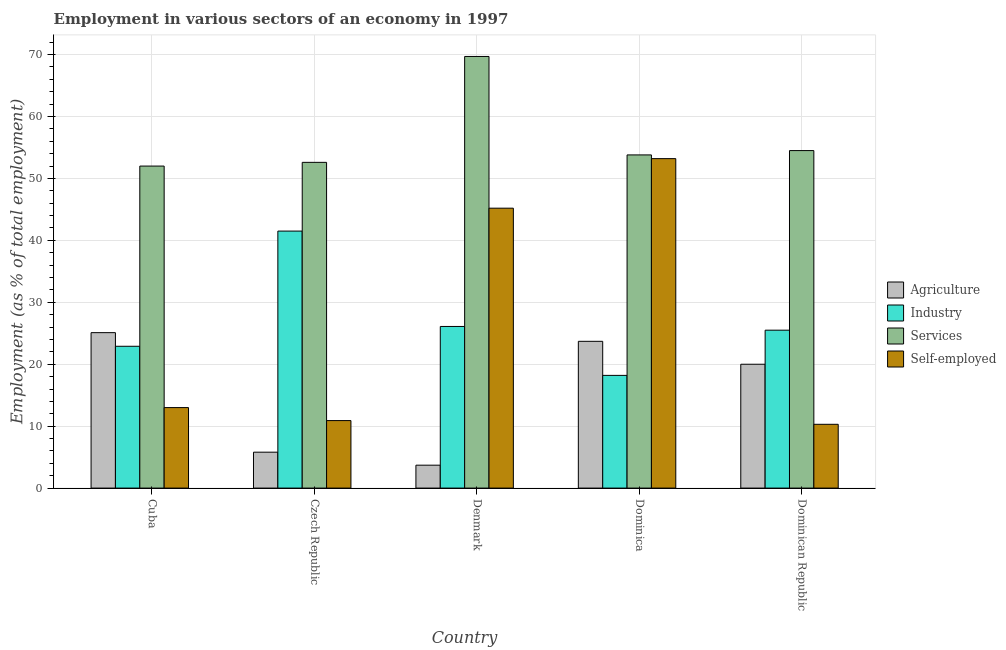How many groups of bars are there?
Your answer should be very brief. 5. Are the number of bars per tick equal to the number of legend labels?
Give a very brief answer. Yes. What is the label of the 4th group of bars from the left?
Your answer should be very brief. Dominica. In how many cases, is the number of bars for a given country not equal to the number of legend labels?
Offer a terse response. 0. What is the percentage of self employed workers in Dominican Republic?
Ensure brevity in your answer.  10.3. Across all countries, what is the maximum percentage of workers in agriculture?
Ensure brevity in your answer.  25.1. Across all countries, what is the minimum percentage of workers in agriculture?
Provide a succinct answer. 3.7. In which country was the percentage of workers in services maximum?
Your answer should be very brief. Denmark. In which country was the percentage of workers in services minimum?
Keep it short and to the point. Cuba. What is the total percentage of workers in agriculture in the graph?
Your response must be concise. 78.3. What is the difference between the percentage of workers in industry in Cuba and that in Denmark?
Offer a terse response. -3.2. What is the difference between the percentage of workers in agriculture in Cuba and the percentage of self employed workers in Dominica?
Provide a succinct answer. -28.1. What is the average percentage of self employed workers per country?
Make the answer very short. 26.52. What is the difference between the percentage of workers in industry and percentage of workers in services in Cuba?
Keep it short and to the point. -29.1. In how many countries, is the percentage of workers in agriculture greater than 26 %?
Provide a succinct answer. 0. What is the ratio of the percentage of workers in industry in Cuba to that in Czech Republic?
Offer a terse response. 0.55. Is the percentage of workers in industry in Denmark less than that in Dominica?
Offer a very short reply. No. Is the difference between the percentage of workers in agriculture in Czech Republic and Denmark greater than the difference between the percentage of workers in services in Czech Republic and Denmark?
Offer a very short reply. Yes. What is the difference between the highest and the second highest percentage of workers in agriculture?
Offer a very short reply. 1.4. What is the difference between the highest and the lowest percentage of workers in agriculture?
Offer a terse response. 21.4. Is it the case that in every country, the sum of the percentage of workers in services and percentage of workers in industry is greater than the sum of percentage of self employed workers and percentage of workers in agriculture?
Your response must be concise. No. What does the 2nd bar from the left in Czech Republic represents?
Ensure brevity in your answer.  Industry. What does the 4th bar from the right in Dominican Republic represents?
Your response must be concise. Agriculture. How many bars are there?
Ensure brevity in your answer.  20. Are all the bars in the graph horizontal?
Make the answer very short. No. How many countries are there in the graph?
Keep it short and to the point. 5. What is the difference between two consecutive major ticks on the Y-axis?
Your answer should be compact. 10. Are the values on the major ticks of Y-axis written in scientific E-notation?
Provide a succinct answer. No. Does the graph contain any zero values?
Make the answer very short. No. Where does the legend appear in the graph?
Keep it short and to the point. Center right. How many legend labels are there?
Provide a short and direct response. 4. What is the title of the graph?
Keep it short and to the point. Employment in various sectors of an economy in 1997. What is the label or title of the Y-axis?
Offer a terse response. Employment (as % of total employment). What is the Employment (as % of total employment) in Agriculture in Cuba?
Offer a terse response. 25.1. What is the Employment (as % of total employment) of Industry in Cuba?
Offer a terse response. 22.9. What is the Employment (as % of total employment) in Agriculture in Czech Republic?
Give a very brief answer. 5.8. What is the Employment (as % of total employment) in Industry in Czech Republic?
Your answer should be compact. 41.5. What is the Employment (as % of total employment) in Services in Czech Republic?
Make the answer very short. 52.6. What is the Employment (as % of total employment) in Self-employed in Czech Republic?
Give a very brief answer. 10.9. What is the Employment (as % of total employment) in Agriculture in Denmark?
Make the answer very short. 3.7. What is the Employment (as % of total employment) in Industry in Denmark?
Give a very brief answer. 26.1. What is the Employment (as % of total employment) in Services in Denmark?
Offer a very short reply. 69.7. What is the Employment (as % of total employment) in Self-employed in Denmark?
Keep it short and to the point. 45.2. What is the Employment (as % of total employment) of Agriculture in Dominica?
Ensure brevity in your answer.  23.7. What is the Employment (as % of total employment) of Industry in Dominica?
Provide a short and direct response. 18.2. What is the Employment (as % of total employment) in Services in Dominica?
Your answer should be very brief. 53.8. What is the Employment (as % of total employment) in Self-employed in Dominica?
Provide a short and direct response. 53.2. What is the Employment (as % of total employment) of Services in Dominican Republic?
Make the answer very short. 54.5. What is the Employment (as % of total employment) in Self-employed in Dominican Republic?
Give a very brief answer. 10.3. Across all countries, what is the maximum Employment (as % of total employment) in Agriculture?
Your answer should be compact. 25.1. Across all countries, what is the maximum Employment (as % of total employment) of Industry?
Provide a succinct answer. 41.5. Across all countries, what is the maximum Employment (as % of total employment) of Services?
Make the answer very short. 69.7. Across all countries, what is the maximum Employment (as % of total employment) of Self-employed?
Make the answer very short. 53.2. Across all countries, what is the minimum Employment (as % of total employment) in Agriculture?
Offer a terse response. 3.7. Across all countries, what is the minimum Employment (as % of total employment) in Industry?
Offer a terse response. 18.2. Across all countries, what is the minimum Employment (as % of total employment) of Services?
Your answer should be compact. 52. Across all countries, what is the minimum Employment (as % of total employment) of Self-employed?
Offer a terse response. 10.3. What is the total Employment (as % of total employment) of Agriculture in the graph?
Ensure brevity in your answer.  78.3. What is the total Employment (as % of total employment) in Industry in the graph?
Your response must be concise. 134.2. What is the total Employment (as % of total employment) in Services in the graph?
Provide a succinct answer. 282.6. What is the total Employment (as % of total employment) of Self-employed in the graph?
Offer a terse response. 132.6. What is the difference between the Employment (as % of total employment) in Agriculture in Cuba and that in Czech Republic?
Provide a short and direct response. 19.3. What is the difference between the Employment (as % of total employment) of Industry in Cuba and that in Czech Republic?
Offer a very short reply. -18.6. What is the difference between the Employment (as % of total employment) of Services in Cuba and that in Czech Republic?
Ensure brevity in your answer.  -0.6. What is the difference between the Employment (as % of total employment) in Self-employed in Cuba and that in Czech Republic?
Offer a very short reply. 2.1. What is the difference between the Employment (as % of total employment) in Agriculture in Cuba and that in Denmark?
Provide a succinct answer. 21.4. What is the difference between the Employment (as % of total employment) in Services in Cuba and that in Denmark?
Your answer should be very brief. -17.7. What is the difference between the Employment (as % of total employment) of Self-employed in Cuba and that in Denmark?
Your response must be concise. -32.2. What is the difference between the Employment (as % of total employment) in Agriculture in Cuba and that in Dominica?
Your answer should be very brief. 1.4. What is the difference between the Employment (as % of total employment) of Services in Cuba and that in Dominica?
Ensure brevity in your answer.  -1.8. What is the difference between the Employment (as % of total employment) of Self-employed in Cuba and that in Dominica?
Offer a very short reply. -40.2. What is the difference between the Employment (as % of total employment) of Agriculture in Cuba and that in Dominican Republic?
Offer a terse response. 5.1. What is the difference between the Employment (as % of total employment) of Industry in Cuba and that in Dominican Republic?
Make the answer very short. -2.6. What is the difference between the Employment (as % of total employment) of Agriculture in Czech Republic and that in Denmark?
Your answer should be very brief. 2.1. What is the difference between the Employment (as % of total employment) of Services in Czech Republic and that in Denmark?
Ensure brevity in your answer.  -17.1. What is the difference between the Employment (as % of total employment) of Self-employed in Czech Republic and that in Denmark?
Offer a very short reply. -34.3. What is the difference between the Employment (as % of total employment) in Agriculture in Czech Republic and that in Dominica?
Your answer should be compact. -17.9. What is the difference between the Employment (as % of total employment) in Industry in Czech Republic and that in Dominica?
Give a very brief answer. 23.3. What is the difference between the Employment (as % of total employment) of Services in Czech Republic and that in Dominica?
Ensure brevity in your answer.  -1.2. What is the difference between the Employment (as % of total employment) in Self-employed in Czech Republic and that in Dominica?
Keep it short and to the point. -42.3. What is the difference between the Employment (as % of total employment) of Agriculture in Czech Republic and that in Dominican Republic?
Your answer should be very brief. -14.2. What is the difference between the Employment (as % of total employment) of Services in Czech Republic and that in Dominican Republic?
Make the answer very short. -1.9. What is the difference between the Employment (as % of total employment) of Self-employed in Czech Republic and that in Dominican Republic?
Provide a succinct answer. 0.6. What is the difference between the Employment (as % of total employment) in Agriculture in Denmark and that in Dominica?
Provide a short and direct response. -20. What is the difference between the Employment (as % of total employment) of Agriculture in Denmark and that in Dominican Republic?
Your answer should be compact. -16.3. What is the difference between the Employment (as % of total employment) of Industry in Denmark and that in Dominican Republic?
Your answer should be very brief. 0.6. What is the difference between the Employment (as % of total employment) in Self-employed in Denmark and that in Dominican Republic?
Provide a short and direct response. 34.9. What is the difference between the Employment (as % of total employment) in Industry in Dominica and that in Dominican Republic?
Your answer should be very brief. -7.3. What is the difference between the Employment (as % of total employment) of Self-employed in Dominica and that in Dominican Republic?
Offer a very short reply. 42.9. What is the difference between the Employment (as % of total employment) of Agriculture in Cuba and the Employment (as % of total employment) of Industry in Czech Republic?
Your answer should be compact. -16.4. What is the difference between the Employment (as % of total employment) of Agriculture in Cuba and the Employment (as % of total employment) of Services in Czech Republic?
Offer a terse response. -27.5. What is the difference between the Employment (as % of total employment) of Industry in Cuba and the Employment (as % of total employment) of Services in Czech Republic?
Give a very brief answer. -29.7. What is the difference between the Employment (as % of total employment) in Industry in Cuba and the Employment (as % of total employment) in Self-employed in Czech Republic?
Provide a short and direct response. 12. What is the difference between the Employment (as % of total employment) in Services in Cuba and the Employment (as % of total employment) in Self-employed in Czech Republic?
Provide a short and direct response. 41.1. What is the difference between the Employment (as % of total employment) of Agriculture in Cuba and the Employment (as % of total employment) of Services in Denmark?
Your response must be concise. -44.6. What is the difference between the Employment (as % of total employment) of Agriculture in Cuba and the Employment (as % of total employment) of Self-employed in Denmark?
Offer a very short reply. -20.1. What is the difference between the Employment (as % of total employment) of Industry in Cuba and the Employment (as % of total employment) of Services in Denmark?
Offer a terse response. -46.8. What is the difference between the Employment (as % of total employment) of Industry in Cuba and the Employment (as % of total employment) of Self-employed in Denmark?
Ensure brevity in your answer.  -22.3. What is the difference between the Employment (as % of total employment) of Services in Cuba and the Employment (as % of total employment) of Self-employed in Denmark?
Keep it short and to the point. 6.8. What is the difference between the Employment (as % of total employment) of Agriculture in Cuba and the Employment (as % of total employment) of Services in Dominica?
Provide a short and direct response. -28.7. What is the difference between the Employment (as % of total employment) of Agriculture in Cuba and the Employment (as % of total employment) of Self-employed in Dominica?
Offer a terse response. -28.1. What is the difference between the Employment (as % of total employment) in Industry in Cuba and the Employment (as % of total employment) in Services in Dominica?
Your response must be concise. -30.9. What is the difference between the Employment (as % of total employment) in Industry in Cuba and the Employment (as % of total employment) in Self-employed in Dominica?
Provide a succinct answer. -30.3. What is the difference between the Employment (as % of total employment) of Services in Cuba and the Employment (as % of total employment) of Self-employed in Dominica?
Keep it short and to the point. -1.2. What is the difference between the Employment (as % of total employment) of Agriculture in Cuba and the Employment (as % of total employment) of Services in Dominican Republic?
Your response must be concise. -29.4. What is the difference between the Employment (as % of total employment) in Industry in Cuba and the Employment (as % of total employment) in Services in Dominican Republic?
Give a very brief answer. -31.6. What is the difference between the Employment (as % of total employment) in Industry in Cuba and the Employment (as % of total employment) in Self-employed in Dominican Republic?
Your response must be concise. 12.6. What is the difference between the Employment (as % of total employment) of Services in Cuba and the Employment (as % of total employment) of Self-employed in Dominican Republic?
Ensure brevity in your answer.  41.7. What is the difference between the Employment (as % of total employment) of Agriculture in Czech Republic and the Employment (as % of total employment) of Industry in Denmark?
Offer a very short reply. -20.3. What is the difference between the Employment (as % of total employment) in Agriculture in Czech Republic and the Employment (as % of total employment) in Services in Denmark?
Offer a terse response. -63.9. What is the difference between the Employment (as % of total employment) in Agriculture in Czech Republic and the Employment (as % of total employment) in Self-employed in Denmark?
Ensure brevity in your answer.  -39.4. What is the difference between the Employment (as % of total employment) of Industry in Czech Republic and the Employment (as % of total employment) of Services in Denmark?
Your response must be concise. -28.2. What is the difference between the Employment (as % of total employment) of Industry in Czech Republic and the Employment (as % of total employment) of Self-employed in Denmark?
Offer a very short reply. -3.7. What is the difference between the Employment (as % of total employment) in Services in Czech Republic and the Employment (as % of total employment) in Self-employed in Denmark?
Provide a short and direct response. 7.4. What is the difference between the Employment (as % of total employment) of Agriculture in Czech Republic and the Employment (as % of total employment) of Services in Dominica?
Make the answer very short. -48. What is the difference between the Employment (as % of total employment) of Agriculture in Czech Republic and the Employment (as % of total employment) of Self-employed in Dominica?
Make the answer very short. -47.4. What is the difference between the Employment (as % of total employment) of Industry in Czech Republic and the Employment (as % of total employment) of Services in Dominica?
Give a very brief answer. -12.3. What is the difference between the Employment (as % of total employment) in Agriculture in Czech Republic and the Employment (as % of total employment) in Industry in Dominican Republic?
Provide a short and direct response. -19.7. What is the difference between the Employment (as % of total employment) in Agriculture in Czech Republic and the Employment (as % of total employment) in Services in Dominican Republic?
Provide a succinct answer. -48.7. What is the difference between the Employment (as % of total employment) of Industry in Czech Republic and the Employment (as % of total employment) of Services in Dominican Republic?
Give a very brief answer. -13. What is the difference between the Employment (as % of total employment) of Industry in Czech Republic and the Employment (as % of total employment) of Self-employed in Dominican Republic?
Offer a terse response. 31.2. What is the difference between the Employment (as % of total employment) in Services in Czech Republic and the Employment (as % of total employment) in Self-employed in Dominican Republic?
Ensure brevity in your answer.  42.3. What is the difference between the Employment (as % of total employment) in Agriculture in Denmark and the Employment (as % of total employment) in Industry in Dominica?
Give a very brief answer. -14.5. What is the difference between the Employment (as % of total employment) of Agriculture in Denmark and the Employment (as % of total employment) of Services in Dominica?
Keep it short and to the point. -50.1. What is the difference between the Employment (as % of total employment) in Agriculture in Denmark and the Employment (as % of total employment) in Self-employed in Dominica?
Keep it short and to the point. -49.5. What is the difference between the Employment (as % of total employment) of Industry in Denmark and the Employment (as % of total employment) of Services in Dominica?
Your response must be concise. -27.7. What is the difference between the Employment (as % of total employment) of Industry in Denmark and the Employment (as % of total employment) of Self-employed in Dominica?
Ensure brevity in your answer.  -27.1. What is the difference between the Employment (as % of total employment) of Agriculture in Denmark and the Employment (as % of total employment) of Industry in Dominican Republic?
Provide a short and direct response. -21.8. What is the difference between the Employment (as % of total employment) in Agriculture in Denmark and the Employment (as % of total employment) in Services in Dominican Republic?
Offer a terse response. -50.8. What is the difference between the Employment (as % of total employment) in Agriculture in Denmark and the Employment (as % of total employment) in Self-employed in Dominican Republic?
Ensure brevity in your answer.  -6.6. What is the difference between the Employment (as % of total employment) of Industry in Denmark and the Employment (as % of total employment) of Services in Dominican Republic?
Ensure brevity in your answer.  -28.4. What is the difference between the Employment (as % of total employment) of Industry in Denmark and the Employment (as % of total employment) of Self-employed in Dominican Republic?
Ensure brevity in your answer.  15.8. What is the difference between the Employment (as % of total employment) of Services in Denmark and the Employment (as % of total employment) of Self-employed in Dominican Republic?
Provide a short and direct response. 59.4. What is the difference between the Employment (as % of total employment) in Agriculture in Dominica and the Employment (as % of total employment) in Services in Dominican Republic?
Offer a terse response. -30.8. What is the difference between the Employment (as % of total employment) in Agriculture in Dominica and the Employment (as % of total employment) in Self-employed in Dominican Republic?
Offer a very short reply. 13.4. What is the difference between the Employment (as % of total employment) of Industry in Dominica and the Employment (as % of total employment) of Services in Dominican Republic?
Ensure brevity in your answer.  -36.3. What is the difference between the Employment (as % of total employment) in Industry in Dominica and the Employment (as % of total employment) in Self-employed in Dominican Republic?
Your answer should be compact. 7.9. What is the difference between the Employment (as % of total employment) of Services in Dominica and the Employment (as % of total employment) of Self-employed in Dominican Republic?
Offer a very short reply. 43.5. What is the average Employment (as % of total employment) of Agriculture per country?
Provide a short and direct response. 15.66. What is the average Employment (as % of total employment) of Industry per country?
Offer a terse response. 26.84. What is the average Employment (as % of total employment) of Services per country?
Your response must be concise. 56.52. What is the average Employment (as % of total employment) of Self-employed per country?
Your answer should be compact. 26.52. What is the difference between the Employment (as % of total employment) of Agriculture and Employment (as % of total employment) of Industry in Cuba?
Offer a very short reply. 2.2. What is the difference between the Employment (as % of total employment) of Agriculture and Employment (as % of total employment) of Services in Cuba?
Provide a succinct answer. -26.9. What is the difference between the Employment (as % of total employment) in Industry and Employment (as % of total employment) in Services in Cuba?
Provide a succinct answer. -29.1. What is the difference between the Employment (as % of total employment) in Services and Employment (as % of total employment) in Self-employed in Cuba?
Provide a short and direct response. 39. What is the difference between the Employment (as % of total employment) of Agriculture and Employment (as % of total employment) of Industry in Czech Republic?
Your response must be concise. -35.7. What is the difference between the Employment (as % of total employment) in Agriculture and Employment (as % of total employment) in Services in Czech Republic?
Offer a terse response. -46.8. What is the difference between the Employment (as % of total employment) in Agriculture and Employment (as % of total employment) in Self-employed in Czech Republic?
Offer a very short reply. -5.1. What is the difference between the Employment (as % of total employment) in Industry and Employment (as % of total employment) in Self-employed in Czech Republic?
Offer a terse response. 30.6. What is the difference between the Employment (as % of total employment) in Services and Employment (as % of total employment) in Self-employed in Czech Republic?
Your response must be concise. 41.7. What is the difference between the Employment (as % of total employment) in Agriculture and Employment (as % of total employment) in Industry in Denmark?
Keep it short and to the point. -22.4. What is the difference between the Employment (as % of total employment) of Agriculture and Employment (as % of total employment) of Services in Denmark?
Offer a terse response. -66. What is the difference between the Employment (as % of total employment) of Agriculture and Employment (as % of total employment) of Self-employed in Denmark?
Offer a very short reply. -41.5. What is the difference between the Employment (as % of total employment) in Industry and Employment (as % of total employment) in Services in Denmark?
Give a very brief answer. -43.6. What is the difference between the Employment (as % of total employment) of Industry and Employment (as % of total employment) of Self-employed in Denmark?
Keep it short and to the point. -19.1. What is the difference between the Employment (as % of total employment) of Agriculture and Employment (as % of total employment) of Industry in Dominica?
Provide a succinct answer. 5.5. What is the difference between the Employment (as % of total employment) of Agriculture and Employment (as % of total employment) of Services in Dominica?
Provide a short and direct response. -30.1. What is the difference between the Employment (as % of total employment) of Agriculture and Employment (as % of total employment) of Self-employed in Dominica?
Offer a very short reply. -29.5. What is the difference between the Employment (as % of total employment) in Industry and Employment (as % of total employment) in Services in Dominica?
Make the answer very short. -35.6. What is the difference between the Employment (as % of total employment) of Industry and Employment (as % of total employment) of Self-employed in Dominica?
Provide a succinct answer. -35. What is the difference between the Employment (as % of total employment) of Agriculture and Employment (as % of total employment) of Industry in Dominican Republic?
Make the answer very short. -5.5. What is the difference between the Employment (as % of total employment) in Agriculture and Employment (as % of total employment) in Services in Dominican Republic?
Make the answer very short. -34.5. What is the difference between the Employment (as % of total employment) in Agriculture and Employment (as % of total employment) in Self-employed in Dominican Republic?
Your answer should be very brief. 9.7. What is the difference between the Employment (as % of total employment) in Industry and Employment (as % of total employment) in Self-employed in Dominican Republic?
Ensure brevity in your answer.  15.2. What is the difference between the Employment (as % of total employment) in Services and Employment (as % of total employment) in Self-employed in Dominican Republic?
Offer a very short reply. 44.2. What is the ratio of the Employment (as % of total employment) of Agriculture in Cuba to that in Czech Republic?
Give a very brief answer. 4.33. What is the ratio of the Employment (as % of total employment) in Industry in Cuba to that in Czech Republic?
Your response must be concise. 0.55. What is the ratio of the Employment (as % of total employment) of Self-employed in Cuba to that in Czech Republic?
Your answer should be compact. 1.19. What is the ratio of the Employment (as % of total employment) of Agriculture in Cuba to that in Denmark?
Provide a succinct answer. 6.78. What is the ratio of the Employment (as % of total employment) of Industry in Cuba to that in Denmark?
Give a very brief answer. 0.88. What is the ratio of the Employment (as % of total employment) in Services in Cuba to that in Denmark?
Your answer should be very brief. 0.75. What is the ratio of the Employment (as % of total employment) of Self-employed in Cuba to that in Denmark?
Ensure brevity in your answer.  0.29. What is the ratio of the Employment (as % of total employment) in Agriculture in Cuba to that in Dominica?
Your answer should be compact. 1.06. What is the ratio of the Employment (as % of total employment) of Industry in Cuba to that in Dominica?
Give a very brief answer. 1.26. What is the ratio of the Employment (as % of total employment) of Services in Cuba to that in Dominica?
Give a very brief answer. 0.97. What is the ratio of the Employment (as % of total employment) in Self-employed in Cuba to that in Dominica?
Your response must be concise. 0.24. What is the ratio of the Employment (as % of total employment) in Agriculture in Cuba to that in Dominican Republic?
Keep it short and to the point. 1.25. What is the ratio of the Employment (as % of total employment) of Industry in Cuba to that in Dominican Republic?
Ensure brevity in your answer.  0.9. What is the ratio of the Employment (as % of total employment) of Services in Cuba to that in Dominican Republic?
Offer a terse response. 0.95. What is the ratio of the Employment (as % of total employment) of Self-employed in Cuba to that in Dominican Republic?
Make the answer very short. 1.26. What is the ratio of the Employment (as % of total employment) in Agriculture in Czech Republic to that in Denmark?
Offer a terse response. 1.57. What is the ratio of the Employment (as % of total employment) of Industry in Czech Republic to that in Denmark?
Ensure brevity in your answer.  1.59. What is the ratio of the Employment (as % of total employment) of Services in Czech Republic to that in Denmark?
Your answer should be compact. 0.75. What is the ratio of the Employment (as % of total employment) of Self-employed in Czech Republic to that in Denmark?
Provide a short and direct response. 0.24. What is the ratio of the Employment (as % of total employment) in Agriculture in Czech Republic to that in Dominica?
Keep it short and to the point. 0.24. What is the ratio of the Employment (as % of total employment) in Industry in Czech Republic to that in Dominica?
Give a very brief answer. 2.28. What is the ratio of the Employment (as % of total employment) in Services in Czech Republic to that in Dominica?
Your answer should be compact. 0.98. What is the ratio of the Employment (as % of total employment) in Self-employed in Czech Republic to that in Dominica?
Provide a short and direct response. 0.2. What is the ratio of the Employment (as % of total employment) in Agriculture in Czech Republic to that in Dominican Republic?
Your answer should be very brief. 0.29. What is the ratio of the Employment (as % of total employment) in Industry in Czech Republic to that in Dominican Republic?
Provide a succinct answer. 1.63. What is the ratio of the Employment (as % of total employment) in Services in Czech Republic to that in Dominican Republic?
Ensure brevity in your answer.  0.97. What is the ratio of the Employment (as % of total employment) in Self-employed in Czech Republic to that in Dominican Republic?
Provide a short and direct response. 1.06. What is the ratio of the Employment (as % of total employment) in Agriculture in Denmark to that in Dominica?
Give a very brief answer. 0.16. What is the ratio of the Employment (as % of total employment) in Industry in Denmark to that in Dominica?
Keep it short and to the point. 1.43. What is the ratio of the Employment (as % of total employment) in Services in Denmark to that in Dominica?
Offer a terse response. 1.3. What is the ratio of the Employment (as % of total employment) in Self-employed in Denmark to that in Dominica?
Your answer should be compact. 0.85. What is the ratio of the Employment (as % of total employment) in Agriculture in Denmark to that in Dominican Republic?
Your answer should be compact. 0.18. What is the ratio of the Employment (as % of total employment) in Industry in Denmark to that in Dominican Republic?
Provide a short and direct response. 1.02. What is the ratio of the Employment (as % of total employment) in Services in Denmark to that in Dominican Republic?
Provide a succinct answer. 1.28. What is the ratio of the Employment (as % of total employment) in Self-employed in Denmark to that in Dominican Republic?
Offer a terse response. 4.39. What is the ratio of the Employment (as % of total employment) of Agriculture in Dominica to that in Dominican Republic?
Ensure brevity in your answer.  1.19. What is the ratio of the Employment (as % of total employment) in Industry in Dominica to that in Dominican Republic?
Ensure brevity in your answer.  0.71. What is the ratio of the Employment (as % of total employment) of Services in Dominica to that in Dominican Republic?
Ensure brevity in your answer.  0.99. What is the ratio of the Employment (as % of total employment) in Self-employed in Dominica to that in Dominican Republic?
Your answer should be very brief. 5.17. What is the difference between the highest and the second highest Employment (as % of total employment) of Industry?
Keep it short and to the point. 15.4. What is the difference between the highest and the second highest Employment (as % of total employment) of Self-employed?
Your answer should be compact. 8. What is the difference between the highest and the lowest Employment (as % of total employment) of Agriculture?
Keep it short and to the point. 21.4. What is the difference between the highest and the lowest Employment (as % of total employment) in Industry?
Provide a succinct answer. 23.3. What is the difference between the highest and the lowest Employment (as % of total employment) in Services?
Provide a succinct answer. 17.7. What is the difference between the highest and the lowest Employment (as % of total employment) in Self-employed?
Give a very brief answer. 42.9. 